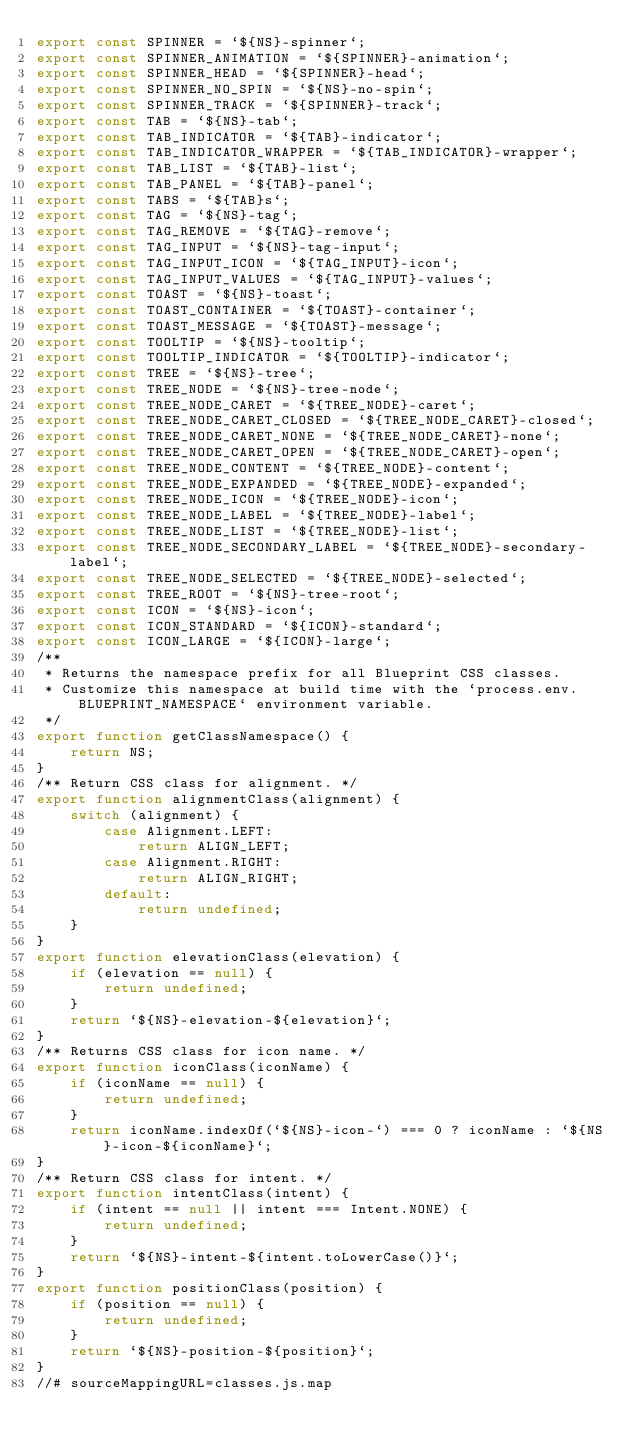<code> <loc_0><loc_0><loc_500><loc_500><_JavaScript_>export const SPINNER = `${NS}-spinner`;
export const SPINNER_ANIMATION = `${SPINNER}-animation`;
export const SPINNER_HEAD = `${SPINNER}-head`;
export const SPINNER_NO_SPIN = `${NS}-no-spin`;
export const SPINNER_TRACK = `${SPINNER}-track`;
export const TAB = `${NS}-tab`;
export const TAB_INDICATOR = `${TAB}-indicator`;
export const TAB_INDICATOR_WRAPPER = `${TAB_INDICATOR}-wrapper`;
export const TAB_LIST = `${TAB}-list`;
export const TAB_PANEL = `${TAB}-panel`;
export const TABS = `${TAB}s`;
export const TAG = `${NS}-tag`;
export const TAG_REMOVE = `${TAG}-remove`;
export const TAG_INPUT = `${NS}-tag-input`;
export const TAG_INPUT_ICON = `${TAG_INPUT}-icon`;
export const TAG_INPUT_VALUES = `${TAG_INPUT}-values`;
export const TOAST = `${NS}-toast`;
export const TOAST_CONTAINER = `${TOAST}-container`;
export const TOAST_MESSAGE = `${TOAST}-message`;
export const TOOLTIP = `${NS}-tooltip`;
export const TOOLTIP_INDICATOR = `${TOOLTIP}-indicator`;
export const TREE = `${NS}-tree`;
export const TREE_NODE = `${NS}-tree-node`;
export const TREE_NODE_CARET = `${TREE_NODE}-caret`;
export const TREE_NODE_CARET_CLOSED = `${TREE_NODE_CARET}-closed`;
export const TREE_NODE_CARET_NONE = `${TREE_NODE_CARET}-none`;
export const TREE_NODE_CARET_OPEN = `${TREE_NODE_CARET}-open`;
export const TREE_NODE_CONTENT = `${TREE_NODE}-content`;
export const TREE_NODE_EXPANDED = `${TREE_NODE}-expanded`;
export const TREE_NODE_ICON = `${TREE_NODE}-icon`;
export const TREE_NODE_LABEL = `${TREE_NODE}-label`;
export const TREE_NODE_LIST = `${TREE_NODE}-list`;
export const TREE_NODE_SECONDARY_LABEL = `${TREE_NODE}-secondary-label`;
export const TREE_NODE_SELECTED = `${TREE_NODE}-selected`;
export const TREE_ROOT = `${NS}-tree-root`;
export const ICON = `${NS}-icon`;
export const ICON_STANDARD = `${ICON}-standard`;
export const ICON_LARGE = `${ICON}-large`;
/**
 * Returns the namespace prefix for all Blueprint CSS classes.
 * Customize this namespace at build time with the `process.env.BLUEPRINT_NAMESPACE` environment variable.
 */
export function getClassNamespace() {
    return NS;
}
/** Return CSS class for alignment. */
export function alignmentClass(alignment) {
    switch (alignment) {
        case Alignment.LEFT:
            return ALIGN_LEFT;
        case Alignment.RIGHT:
            return ALIGN_RIGHT;
        default:
            return undefined;
    }
}
export function elevationClass(elevation) {
    if (elevation == null) {
        return undefined;
    }
    return `${NS}-elevation-${elevation}`;
}
/** Returns CSS class for icon name. */
export function iconClass(iconName) {
    if (iconName == null) {
        return undefined;
    }
    return iconName.indexOf(`${NS}-icon-`) === 0 ? iconName : `${NS}-icon-${iconName}`;
}
/** Return CSS class for intent. */
export function intentClass(intent) {
    if (intent == null || intent === Intent.NONE) {
        return undefined;
    }
    return `${NS}-intent-${intent.toLowerCase()}`;
}
export function positionClass(position) {
    if (position == null) {
        return undefined;
    }
    return `${NS}-position-${position}`;
}
//# sourceMappingURL=classes.js.map</code> 